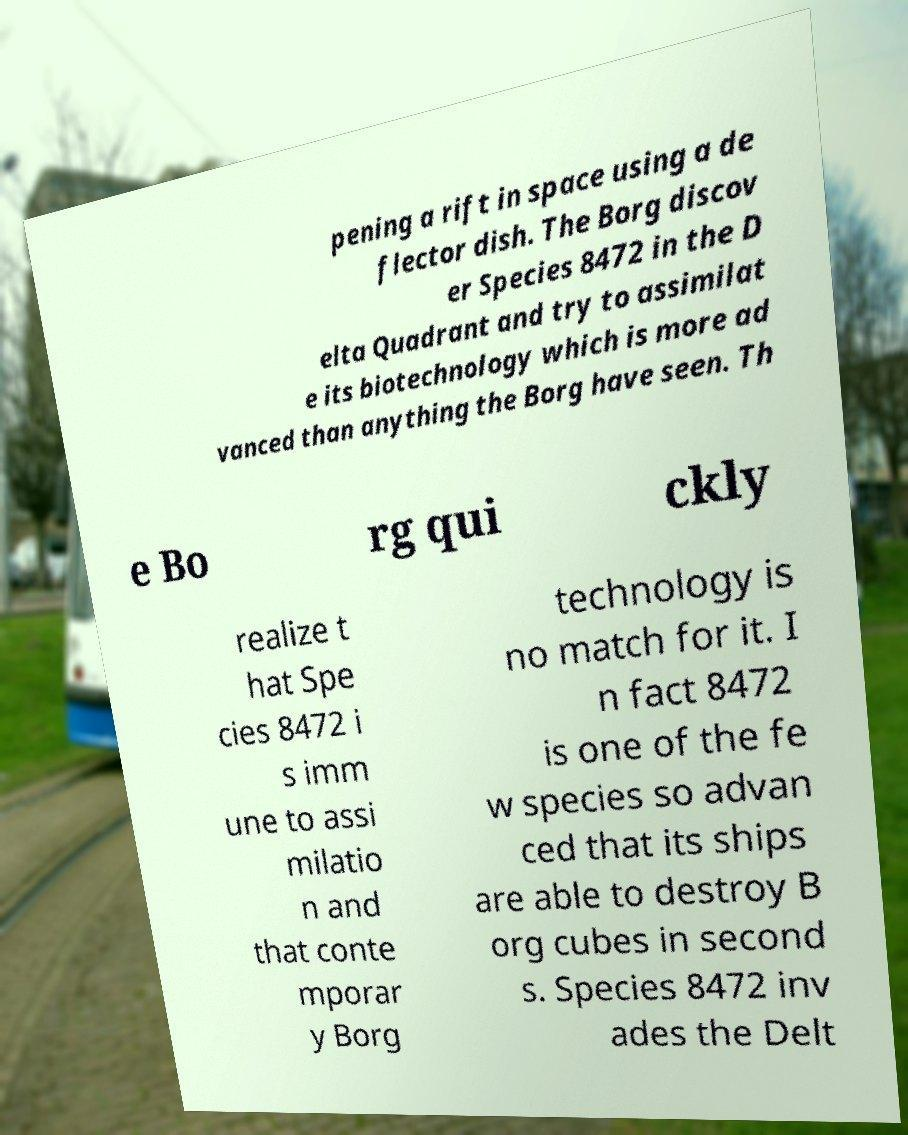Could you extract and type out the text from this image? pening a rift in space using a de flector dish. The Borg discov er Species 8472 in the D elta Quadrant and try to assimilat e its biotechnology which is more ad vanced than anything the Borg have seen. Th e Bo rg qui ckly realize t hat Spe cies 8472 i s imm une to assi milatio n and that conte mporar y Borg technology is no match for it. I n fact 8472 is one of the fe w species so advan ced that its ships are able to destroy B org cubes in second s. Species 8472 inv ades the Delt 